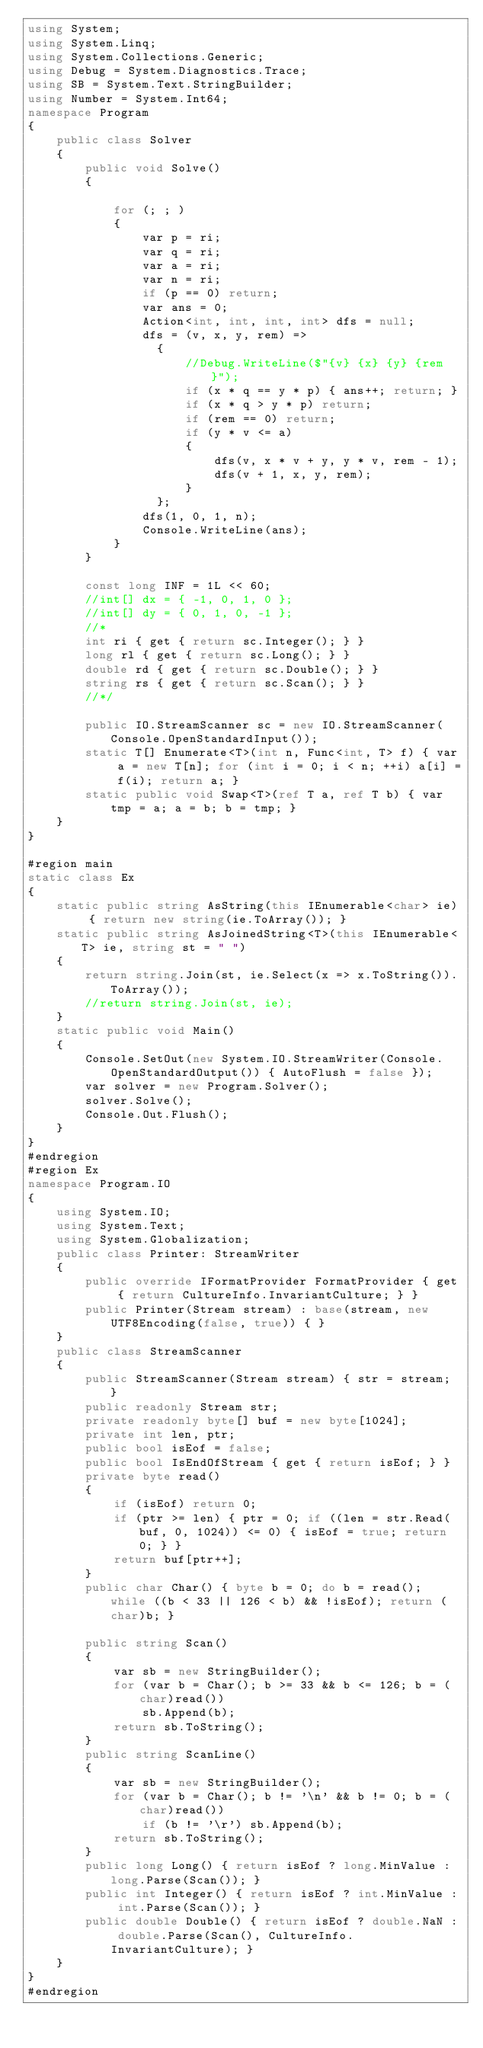Convert code to text. <code><loc_0><loc_0><loc_500><loc_500><_C#_>using System;
using System.Linq;
using System.Collections.Generic;
using Debug = System.Diagnostics.Trace;
using SB = System.Text.StringBuilder;
using Number = System.Int64;
namespace Program
{
    public class Solver
    {
        public void Solve()
        {

            for (; ; )
            {
                var p = ri;
                var q = ri;
                var a = ri;
                var n = ri;
                if (p == 0) return;
                var ans = 0;
                Action<int, int, int, int> dfs = null;
                dfs = (v, x, y, rem) =>
                  {
                      //Debug.WriteLine($"{v} {x} {y} {rem}");
                      if (x * q == y * p) { ans++; return; }
                      if (x * q > y * p) return;
                      if (rem == 0) return;
                      if (y * v <= a)
                      {
                          dfs(v, x * v + y, y * v, rem - 1);
                          dfs(v + 1, x, y, rem);
                      }
                  };
                dfs(1, 0, 1, n);
                Console.WriteLine(ans);
            }
        }

        const long INF = 1L << 60;
        //int[] dx = { -1, 0, 1, 0 };
        //int[] dy = { 0, 1, 0, -1 };
        //*
        int ri { get { return sc.Integer(); } }
        long rl { get { return sc.Long(); } }
        double rd { get { return sc.Double(); } }
        string rs { get { return sc.Scan(); } }
        //*/

        public IO.StreamScanner sc = new IO.StreamScanner(Console.OpenStandardInput());
        static T[] Enumerate<T>(int n, Func<int, T> f) { var a = new T[n]; for (int i = 0; i < n; ++i) a[i] = f(i); return a; }
        static public void Swap<T>(ref T a, ref T b) { var tmp = a; a = b; b = tmp; }
    }
}

#region main
static class Ex
{
    static public string AsString(this IEnumerable<char> ie) { return new string(ie.ToArray()); }
    static public string AsJoinedString<T>(this IEnumerable<T> ie, string st = " ")
    {
        return string.Join(st, ie.Select(x => x.ToString()).ToArray());
        //return string.Join(st, ie);
    }
    static public void Main()
    {
        Console.SetOut(new System.IO.StreamWriter(Console.OpenStandardOutput()) { AutoFlush = false });
        var solver = new Program.Solver();
        solver.Solve();
        Console.Out.Flush();
    }
}
#endregion
#region Ex
namespace Program.IO
{
    using System.IO;
    using System.Text;
    using System.Globalization;
    public class Printer: StreamWriter
    {
        public override IFormatProvider FormatProvider { get { return CultureInfo.InvariantCulture; } }
        public Printer(Stream stream) : base(stream, new UTF8Encoding(false, true)) { }
    }
    public class StreamScanner
    {
        public StreamScanner(Stream stream) { str = stream; }
        public readonly Stream str;
        private readonly byte[] buf = new byte[1024];
        private int len, ptr;
        public bool isEof = false;
        public bool IsEndOfStream { get { return isEof; } }
        private byte read()
        {
            if (isEof) return 0;
            if (ptr >= len) { ptr = 0; if ((len = str.Read(buf, 0, 1024)) <= 0) { isEof = true; return 0; } }
            return buf[ptr++];
        }
        public char Char() { byte b = 0; do b = read(); while ((b < 33 || 126 < b) && !isEof); return (char)b; }

        public string Scan()
        {
            var sb = new StringBuilder();
            for (var b = Char(); b >= 33 && b <= 126; b = (char)read())
                sb.Append(b);
            return sb.ToString();
        }
        public string ScanLine()
        {
            var sb = new StringBuilder();
            for (var b = Char(); b != '\n' && b != 0; b = (char)read())
                if (b != '\r') sb.Append(b);
            return sb.ToString();
        }
        public long Long() { return isEof ? long.MinValue : long.Parse(Scan()); }
        public int Integer() { return isEof ? int.MinValue : int.Parse(Scan()); }
        public double Double() { return isEof ? double.NaN : double.Parse(Scan(), CultureInfo.InvariantCulture); }
    }
}
#endregion
</code> 